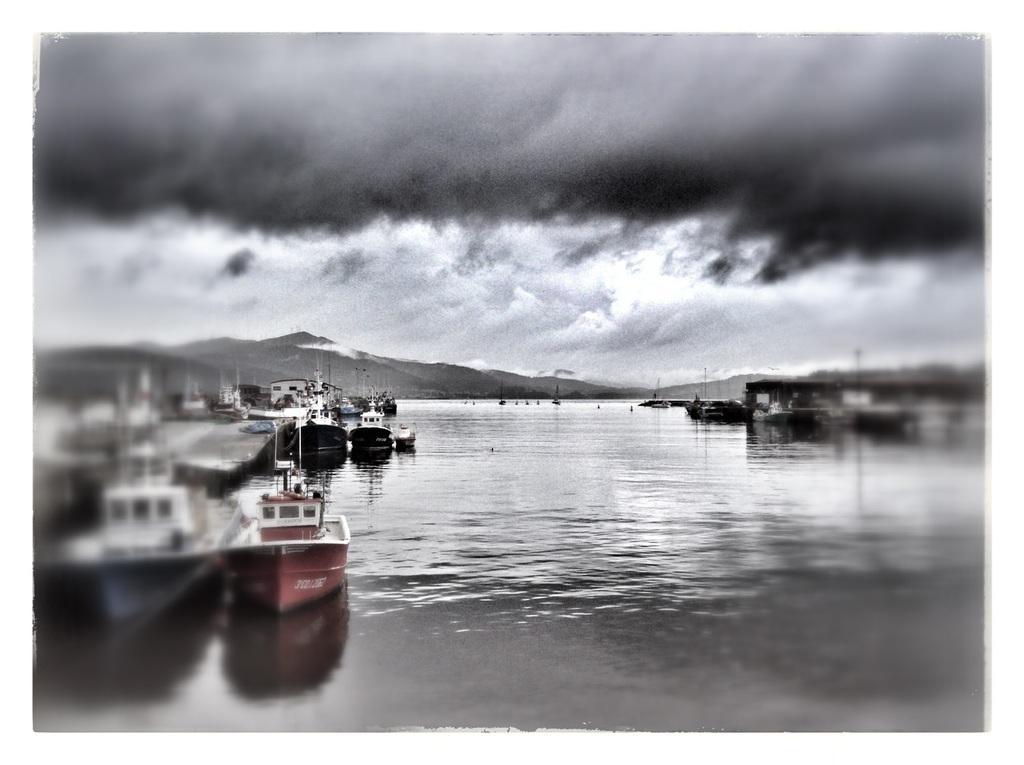Could you give a brief overview of what you see in this image? In the left side there is a boat which is in dark red color. In the middle there is water, At the top it's a cloudy sky. 